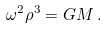Convert formula to latex. <formula><loc_0><loc_0><loc_500><loc_500>\omega ^ { 2 } \rho ^ { 3 } = G M \, .</formula> 